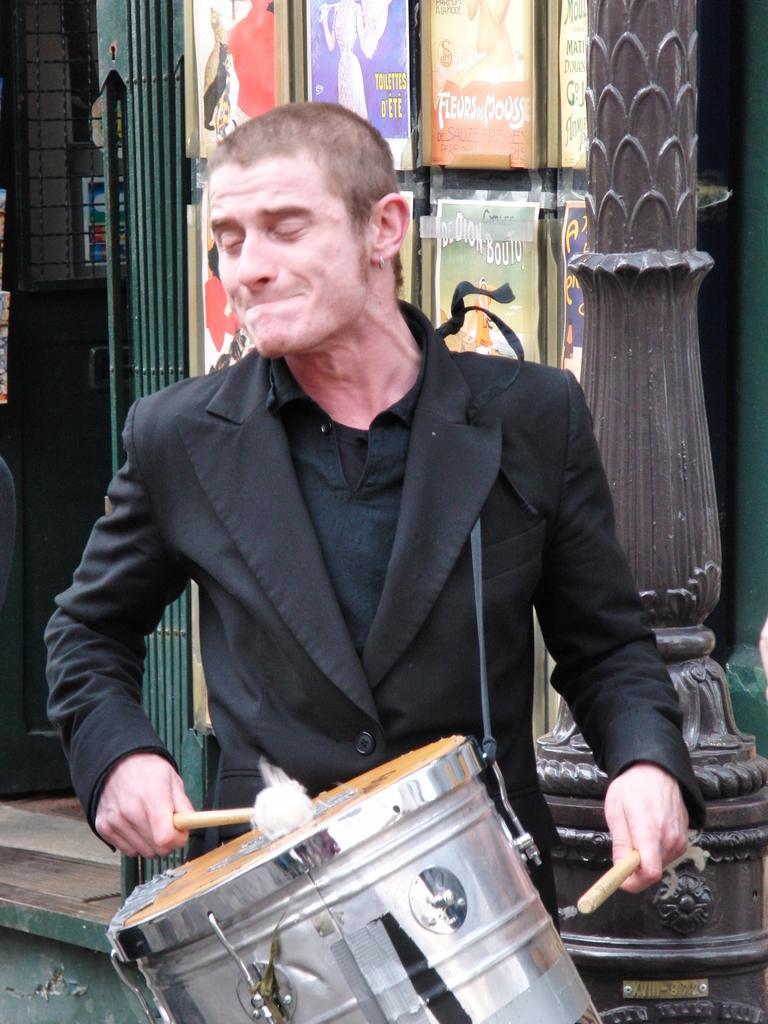Could you give a brief overview of what you see in this image? A man is playing drum, these are posters. 